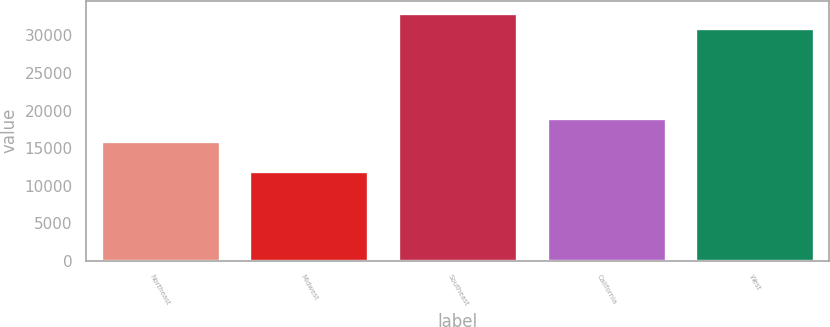<chart> <loc_0><loc_0><loc_500><loc_500><bar_chart><fcel>Northeast<fcel>Midwest<fcel>Southeast<fcel>California<fcel>West<nl><fcel>16000<fcel>12000<fcel>33000<fcel>19000<fcel>31000<nl></chart> 